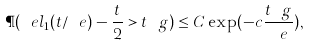<formula> <loc_0><loc_0><loc_500><loc_500>\P ( \ e l _ { 1 } ( t / \ e ) - \frac { t } { 2 } > t \ g ) \leq C \exp ( - c \frac { t \ g } { \ e } ) ,</formula> 